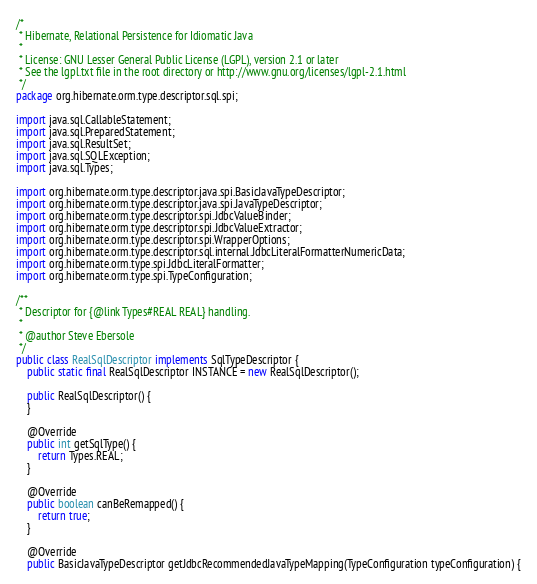<code> <loc_0><loc_0><loc_500><loc_500><_Java_>/*
 * Hibernate, Relational Persistence for Idiomatic Java
 *
 * License: GNU Lesser General Public License (LGPL), version 2.1 or later
 * See the lgpl.txt file in the root directory or http://www.gnu.org/licenses/lgpl-2.1.html
 */
package org.hibernate.orm.type.descriptor.sql.spi;

import java.sql.CallableStatement;
import java.sql.PreparedStatement;
import java.sql.ResultSet;
import java.sql.SQLException;
import java.sql.Types;

import org.hibernate.orm.type.descriptor.java.spi.BasicJavaTypeDescriptor;
import org.hibernate.orm.type.descriptor.java.spi.JavaTypeDescriptor;
import org.hibernate.orm.type.descriptor.spi.JdbcValueBinder;
import org.hibernate.orm.type.descriptor.spi.JdbcValueExtractor;
import org.hibernate.orm.type.descriptor.spi.WrapperOptions;
import org.hibernate.orm.type.descriptor.sql.internal.JdbcLiteralFormatterNumericData;
import org.hibernate.orm.type.spi.JdbcLiteralFormatter;
import org.hibernate.orm.type.spi.TypeConfiguration;

/**
 * Descriptor for {@link Types#REAL REAL} handling.
 *
 * @author Steve Ebersole
 */
public class RealSqlDescriptor implements SqlTypeDescriptor {
	public static final RealSqlDescriptor INSTANCE = new RealSqlDescriptor();

	public RealSqlDescriptor() {
	}

	@Override
	public int getSqlType() {
		return Types.REAL;
	}

	@Override
	public boolean canBeRemapped() {
		return true;
	}

	@Override
	public BasicJavaTypeDescriptor getJdbcRecommendedJavaTypeMapping(TypeConfiguration typeConfiguration) {</code> 